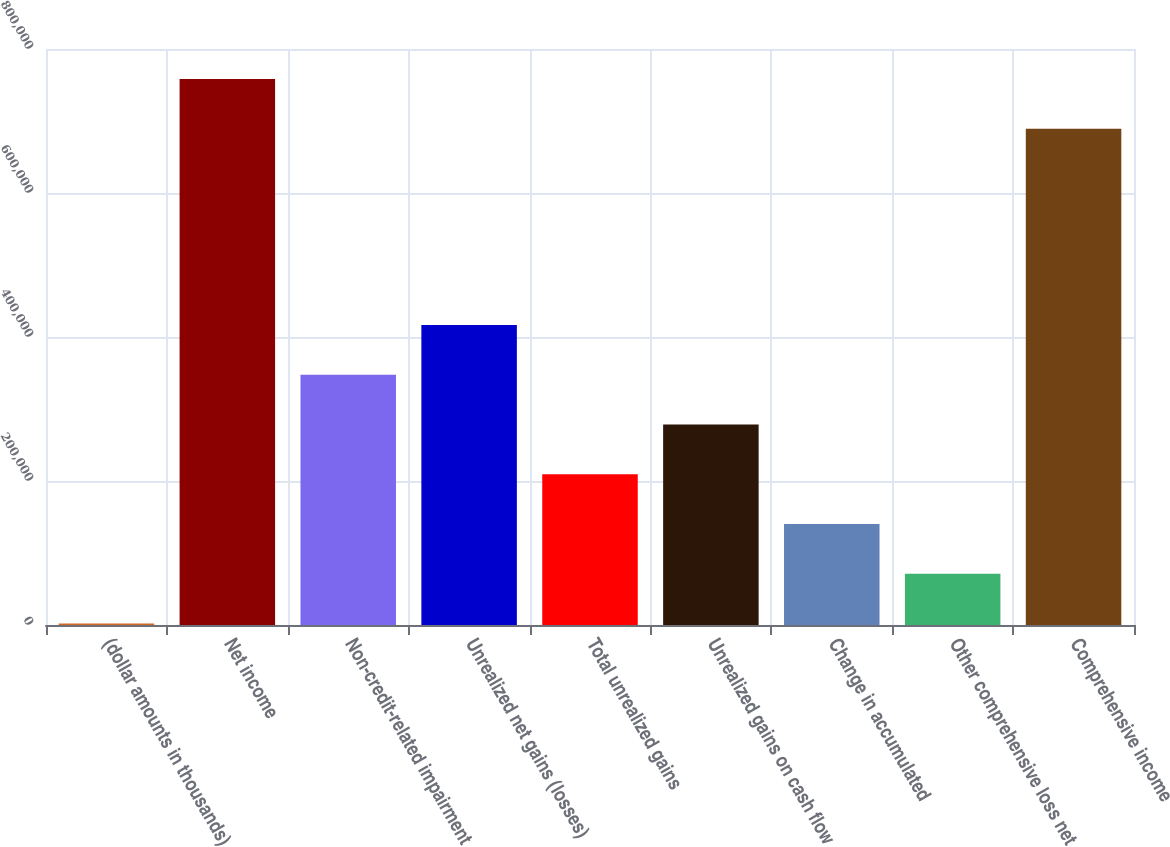<chart> <loc_0><loc_0><loc_500><loc_500><bar_chart><fcel>(dollar amounts in thousands)<fcel>Net income<fcel>Non-credit-related impairment<fcel>Unrealized net gains (losses)<fcel>Total unrealized gains<fcel>Unrealized gains on cash flow<fcel>Change in accumulated<fcel>Other comprehensive loss net<fcel>Comprehensive income<nl><fcel>2015<fcel>758185<fcel>347486<fcel>416580<fcel>209298<fcel>278392<fcel>140203<fcel>71109.2<fcel>689091<nl></chart> 